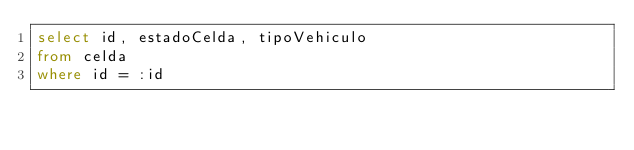<code> <loc_0><loc_0><loc_500><loc_500><_SQL_>select id, estadoCelda, tipoVehiculo
from celda
where id = :id</code> 